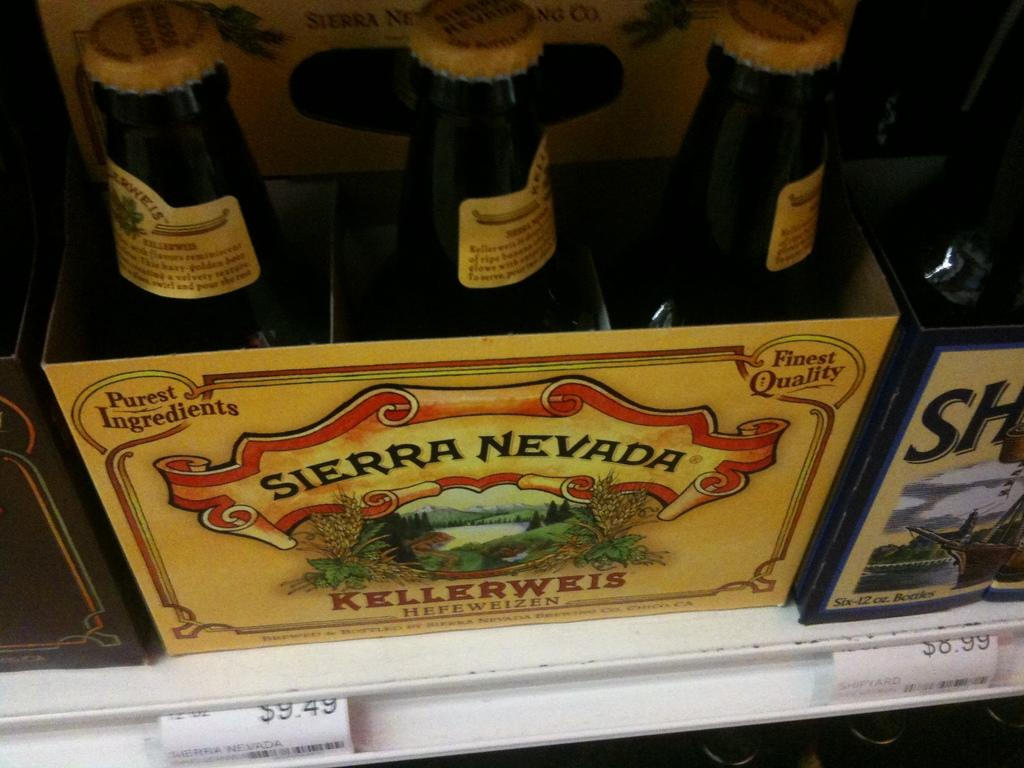<image>
Provide a brief description of the given image. Six pack box of Sierra Nevada Kellerweis beer bottles with metal caps. 